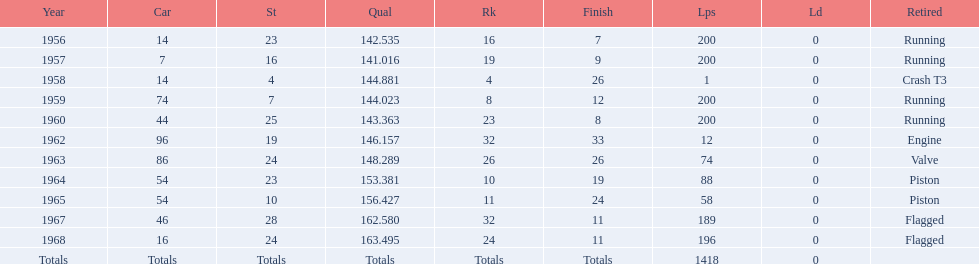How many times did he finish all 200 laps? 4. 